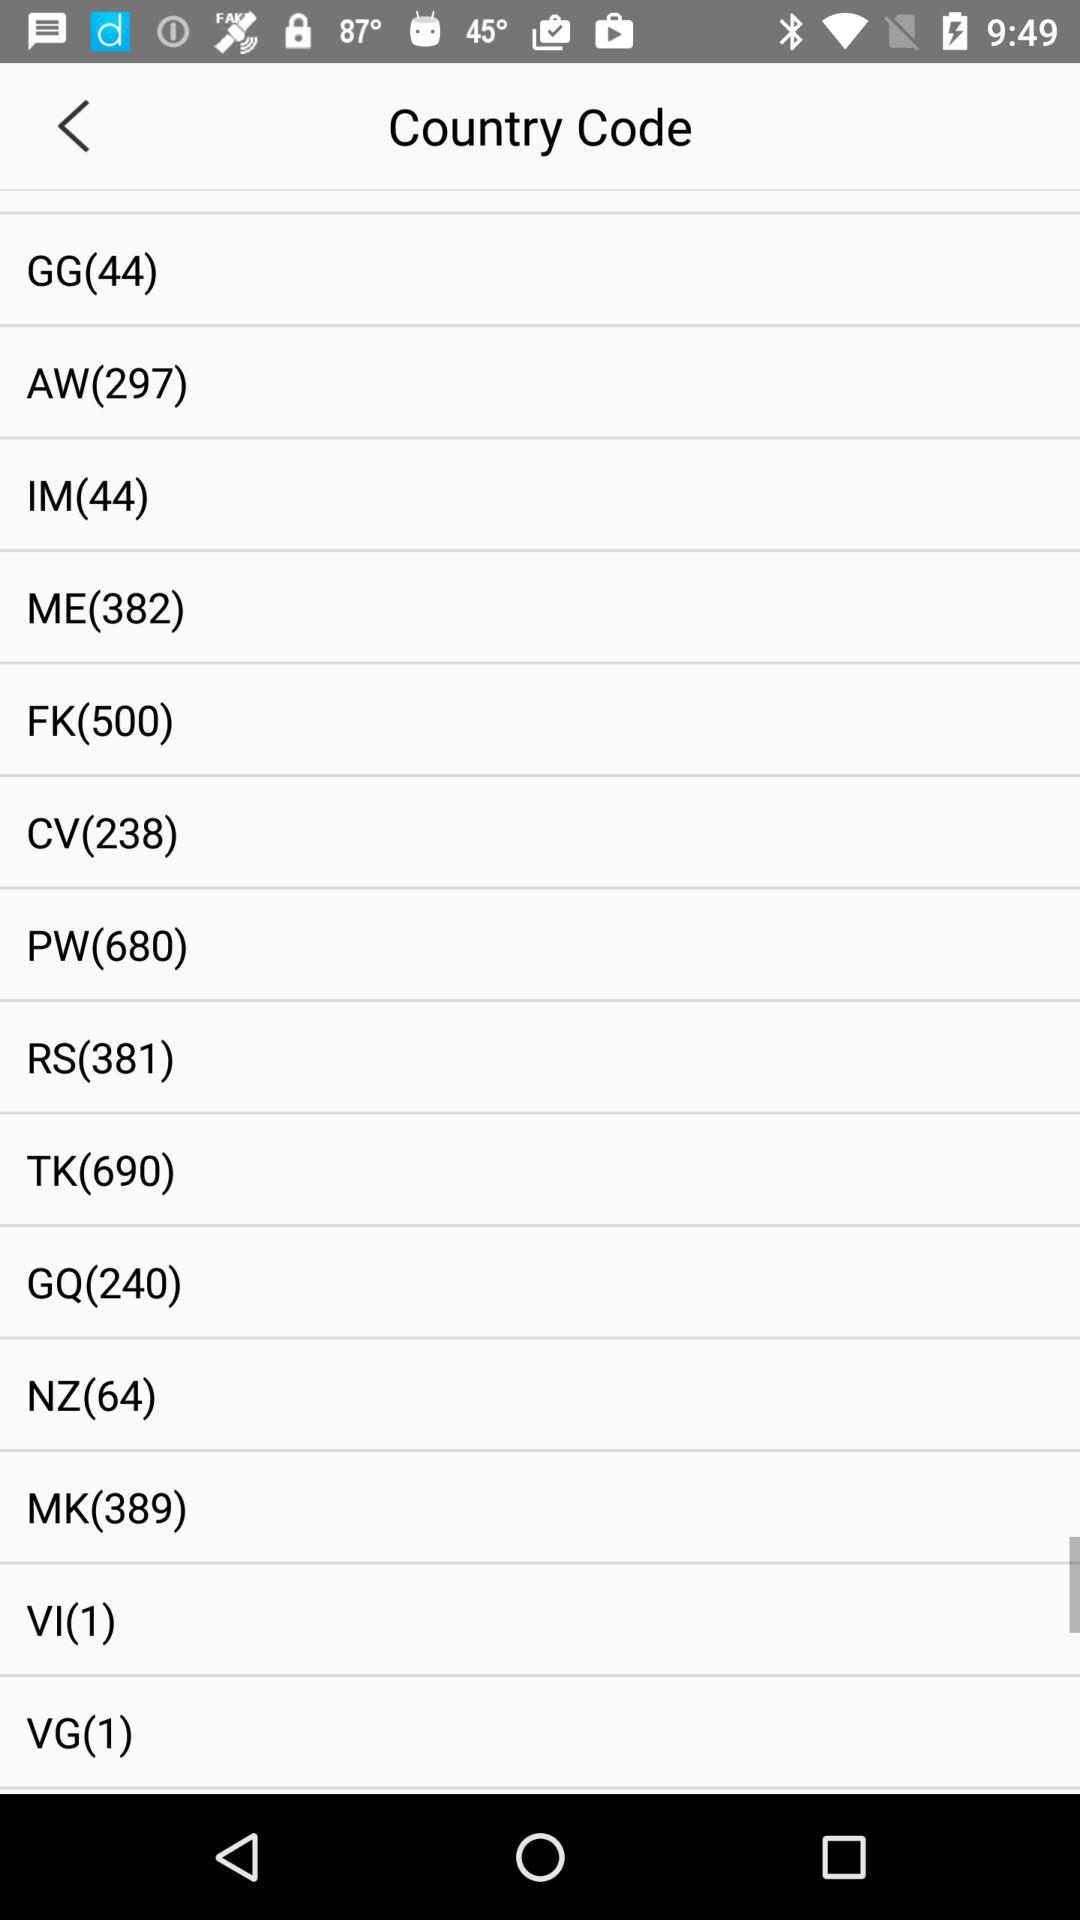What is the country code for the United States? The country code is 1. 